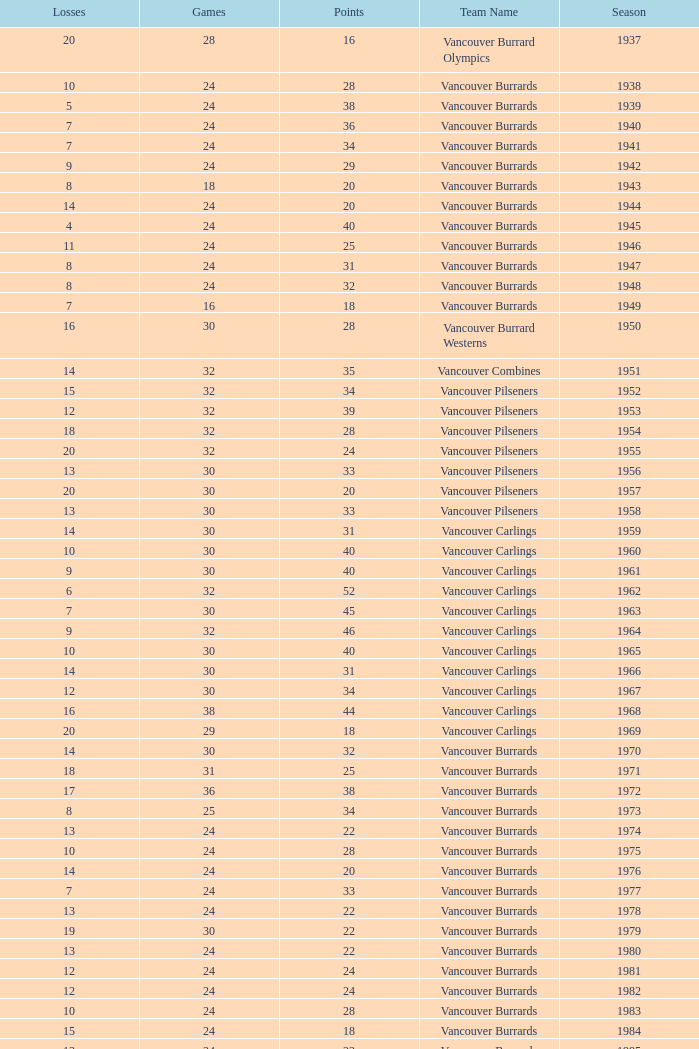What's the lowest number of points with fewer than 8 losses and fewer than 24 games for the vancouver burrards? 18.0. 